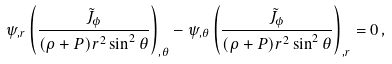<formula> <loc_0><loc_0><loc_500><loc_500>\psi _ { , r } \left ( \frac { \tilde { J } _ { \phi } } { ( \rho + P ) r ^ { 2 } \sin ^ { 2 } { \theta } } \right ) _ { , \theta } - \psi _ { , \theta } \left ( \frac { \tilde { J } _ { \phi } } { ( \rho + P ) r ^ { 2 } \sin ^ { 2 } { \theta } } \right ) _ { , r } = 0 \, ,</formula> 